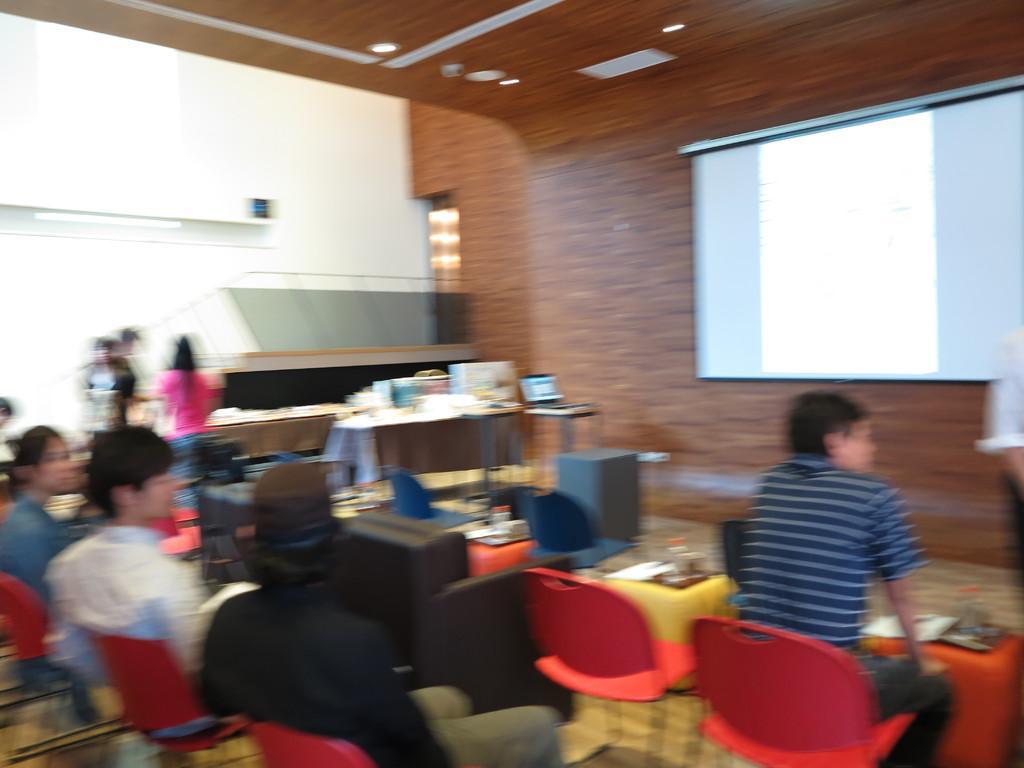Could you give a brief overview of what you see in this image? In this image we can see people are sitting on red color chairs. In the background of the image, we can see board, wall, table, laptop, people and so many objects. There is a roof at the top of the image. 